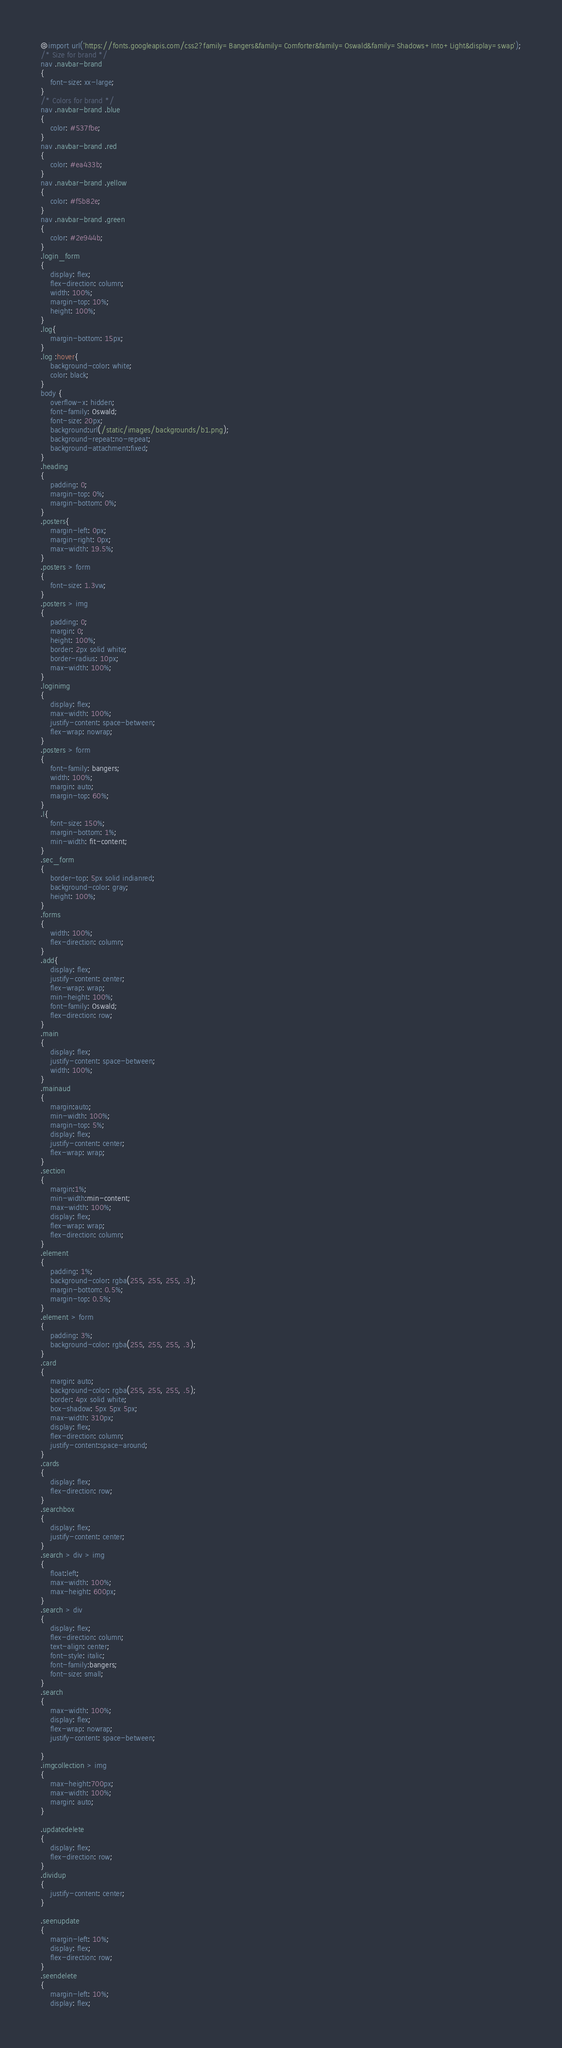Convert code to text. <code><loc_0><loc_0><loc_500><loc_500><_CSS_>@import url('https://fonts.googleapis.com/css2?family=Bangers&family=Comforter&family=Oswald&family=Shadows+Into+Light&display=swap');
/* Size for brand */
nav .navbar-brand
{
    font-size: xx-large;
}
/* Colors for brand */
nav .navbar-brand .blue
{
    color: #537fbe;
}
nav .navbar-brand .red
{
    color: #ea433b;
}
nav .navbar-brand .yellow
{
    color: #f5b82e;
}
nav .navbar-brand .green
{
    color: #2e944b;
}
.login_form
{
    display: flex;
    flex-direction: column;
    width: 100%;
    margin-top: 10%;
    height: 100%;
}
.log{
    margin-bottom: 15px;
}
.log :hover{
    background-color: white;
    color: black;
}
body {
    overflow-x: hidden;
    font-family: Oswald;
    font-size: 20px;
    background:url(/static/images/backgrounds/b1.png);
    background-repeat:no-repeat;
    background-attachment:fixed;
}
.heading
{
    padding: 0;
    margin-top: 0%;
    margin-bottom: 0%;
}
.posters{
    margin-left: 0px;
    margin-right: 0px;
    max-width: 19.5%;
}
.posters > form
{
    font-size: 1.3vw;
}
.posters > img
{
    padding: 0;
    margin: 0;
    height: 100%;
    border: 2px solid white;
    border-radius: 10px;
    max-width: 100%;
}
.loginimg
{
    display: flex;
    max-width: 100%;
    justify-content: space-between;
    flex-wrap: nowrap;
}
.posters > form
{
    font-family: bangers;
    width: 100%;
    margin: auto;
    margin-top: 60%;
}
.l{
    font-size: 150%;
    margin-bottom: 1%;
    min-width: fit-content;
}
.sec_form
{
    border-top: 5px solid indianred;
    background-color: gray;
    height: 100%;
}
.forms
{
    width: 100%;
    flex-direction: column;
}
.add{
    display: flex;
    justify-content: center;
    flex-wrap: wrap;
    min-height: 100%;
    font-family: Oswald;
    flex-direction: row;
}
.main
{
    display: flex;
    justify-content: space-between;
    width: 100%;
}
.mainaud
{
    margin:auto;
    min-width: 100%;
    margin-top: 5%;
    display: flex;
    justify-content: center;
    flex-wrap: wrap;
}
.section
{
    margin:1%;
    min-width:min-content;
    max-width: 100%;
    display: flex;
    flex-wrap: wrap;
    flex-direction: column;
}
.element
{    
    padding: 1%;
    background-color: rgba(255, 255, 255, .3);
    margin-bottom: 0.5%;
    margin-top: 0.5%;
}
.element > form
{
    padding: 3%;
    background-color: rgba(255, 255, 255, .3);
}
.card
{
    margin: auto;
    background-color: rgba(255, 255, 255, .5);
    border: 4px solid white;
    box-shadow: 5px 5px 5px;
    max-width: 310px;
    display: flex;
    flex-direction: column;
    justify-content:space-around;
}
.cards
{
    display: flex;
    flex-direction: row;
}
.searchbox
{
    display: flex;
    justify-content: center;
}
.search > div > img
{
    float:left;
    max-width: 100%;
    max-height: 600px;
}
.search > div 
{
    display: flex;
    flex-direction: column;
    text-align: center;
    font-style: italic;
    font-family:bangers;
    font-size: small;   
}
.search
{
    max-width: 100%;
    display: flex;
    flex-wrap: nowrap;
    justify-content: space-between;
    
}
.imgcollection > img
{
    max-height:700px;
    max-width: 100%;
    margin: auto;
}

.updatedelete
{
    display: flex;
    flex-direction: row;
}
.dividup
{
    justify-content: center;    
}

.seenupdate
{
    margin-left: 10%;
    display: flex;
    flex-direction: row;
}
.seendelete
{
    margin-left: 10%;
    display: flex;</code> 